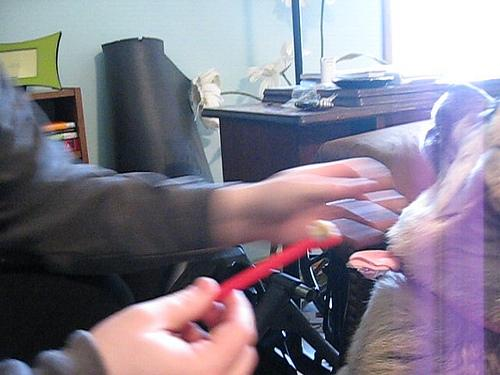What is the person trying to do to the dog? Please explain your reasoning. brush teeth. They have a toothbrush and trying to put it in the mouth 